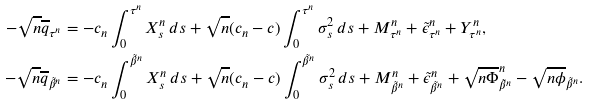<formula> <loc_0><loc_0><loc_500><loc_500>- \sqrt { n } \overline { q } _ { \tau ^ { n } } & = - c _ { n } \int _ { 0 } ^ { \tau ^ { n } } X ^ { n } _ { s } \, d s + \sqrt { n } ( c _ { n } - c ) \int _ { 0 } ^ { \tau ^ { n } } \sigma _ { s } ^ { 2 } \, d s + M ^ { n } _ { \tau ^ { n } } + \tilde { \epsilon } ^ { n } _ { \tau ^ { n } } + Y ^ { n } _ { \tau ^ { n } } , \\ - \sqrt { n } \overline { q } _ { \tilde { \beta } ^ { n } } & = - c _ { n } \int _ { 0 } ^ { \tilde { \beta } ^ { n } } X ^ { n } _ { s } \, d s + \sqrt { n } ( c _ { n } - c ) \int _ { 0 } ^ { \tilde { \beta } ^ { n } } \sigma _ { s } ^ { 2 } \, d s + M ^ { n } _ { \tilde { \beta } ^ { n } } + \tilde { \epsilon } ^ { n } _ { \tilde { \beta } ^ { n } } + \sqrt { n } \overline { \Phi } ^ { n } _ { \tilde { \beta } ^ { n } } - \sqrt { n } \overline { \phi } _ { \tilde { \beta } ^ { n } } .</formula> 